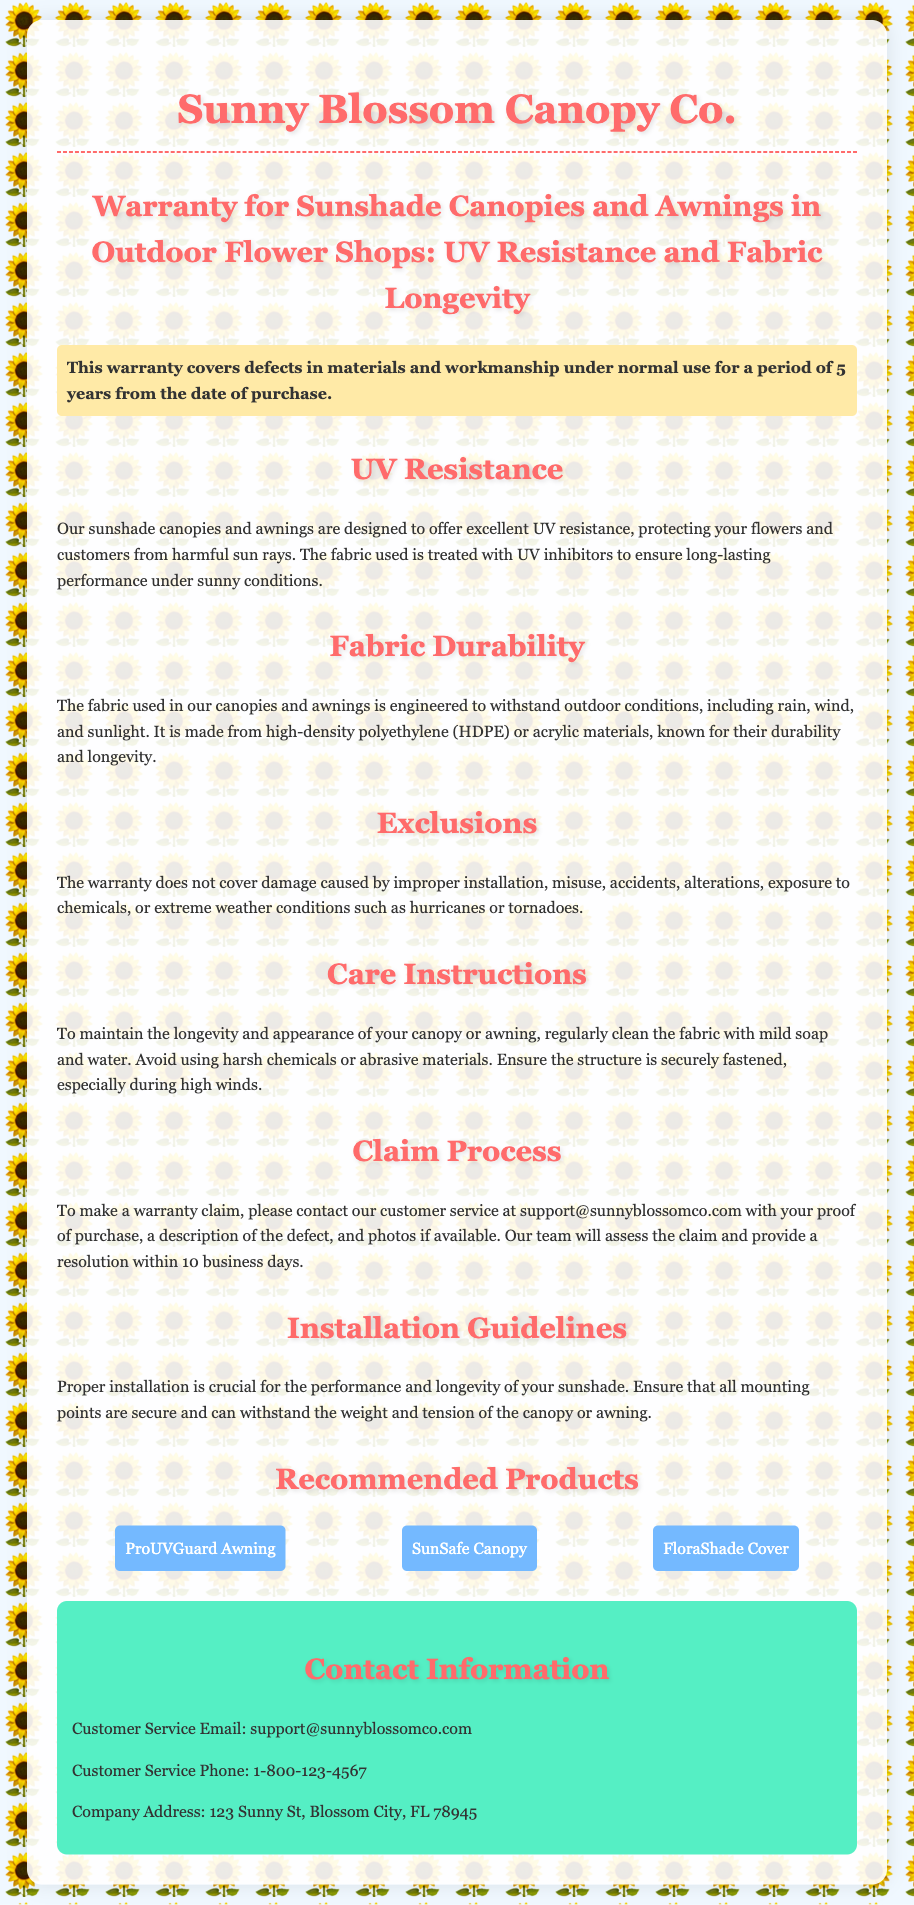What is the warranty period for the canopies? The warranty covers defects in materials and workmanship for a period of 5 years from the date of purchase.
Answer: 5 years What is the main material used in the canopies? The fabric is made from high-density polyethylene (HDPE) or acrylic materials.
Answer: HDPE or acrylic What should be avoided when cleaning the fabric? Harsh chemicals or abrasive materials should be avoided to maintain the fabric's appearance and longevity.
Answer: Harsh chemicals What is required to make a warranty claim? To make a warranty claim, you need to contact customer service with proof of purchase and a description of the defect.
Answer: Proof of purchase What condition voids the warranty? Damage caused by improper installation voids the warranty.
Answer: Improper installation How long will it take to assess a warranty claim? The assessment of a warranty claim will be provided within 10 business days.
Answer: 10 business days What type of protection do the canopies offer? The canopies are designed to offer excellent UV resistance.
Answer: UV resistance What is the company address? The company address is listed in the document for customer service inquiries.
Answer: 123 Sunny St, Blossom City, FL 78945 